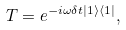<formula> <loc_0><loc_0><loc_500><loc_500>T = e ^ { - i \omega \delta t | 1 \rangle \langle 1 | } ,</formula> 